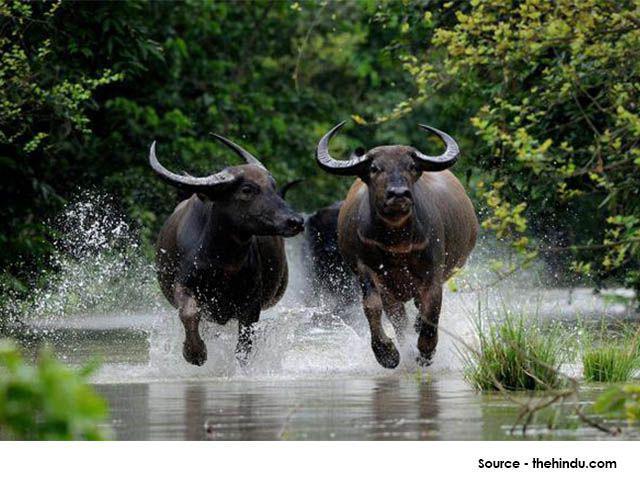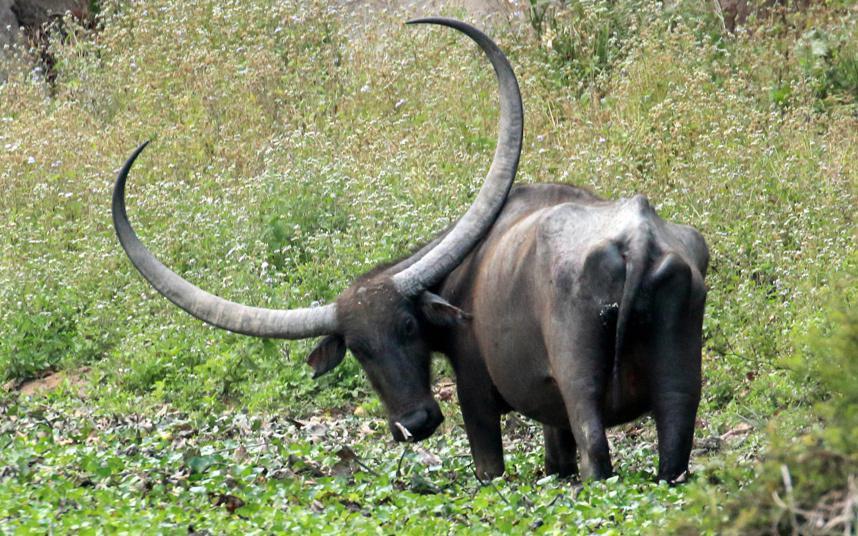The first image is the image on the left, the second image is the image on the right. Examine the images to the left and right. Is the description "Left image shows water buffalo upright in water." accurate? Answer yes or no. Yes. The first image is the image on the left, the second image is the image on the right. Assess this claim about the two images: "At least one water buffalo is standing in water.". Correct or not? Answer yes or no. Yes. 